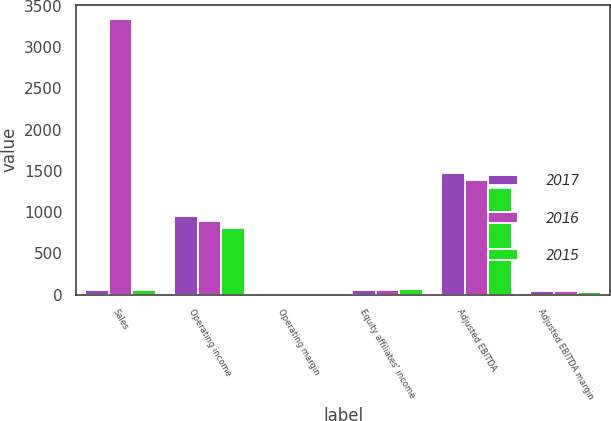Convert chart to OTSL. <chart><loc_0><loc_0><loc_500><loc_500><stacked_bar_chart><ecel><fcel>Sales<fcel>Operating income<fcel>Operating margin<fcel>Equity affiliates' income<fcel>Adjusted EBITDA<fcel>Adjusted EBITDA margin<nl><fcel>2017<fcel>61.35<fcel>950.6<fcel>26.1<fcel>58.1<fcel>1473.1<fcel>40.5<nl><fcel>2016<fcel>3344.1<fcel>893.2<fcel>26.7<fcel>52.7<fcel>1389.5<fcel>41.6<nl><fcel>2015<fcel>61.35<fcel>806.1<fcel>21.8<fcel>64.6<fcel>1288.2<fcel>34.9<nl></chart> 